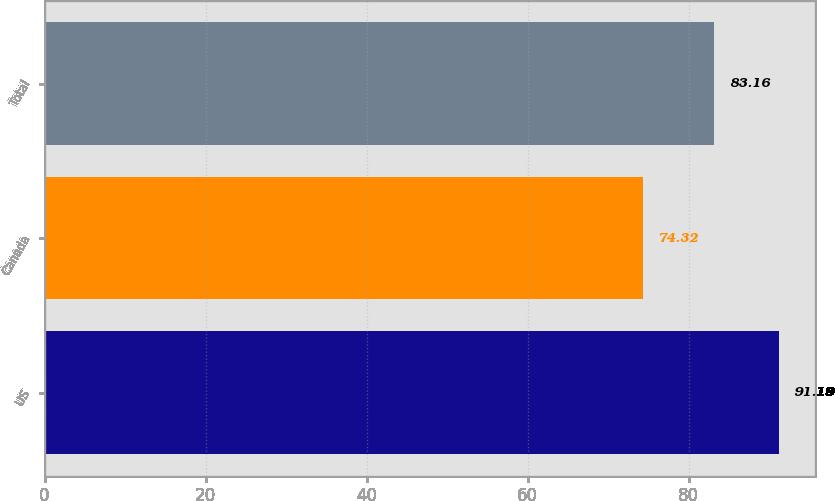Convert chart. <chart><loc_0><loc_0><loc_500><loc_500><bar_chart><fcel>US<fcel>Canada<fcel>Total<nl><fcel>91.19<fcel>74.32<fcel>83.16<nl></chart> 